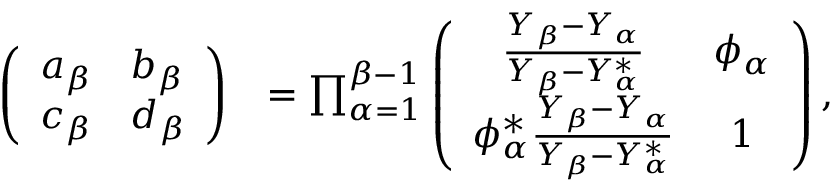<formula> <loc_0><loc_0><loc_500><loc_500>\begin{array} { r l } { \left ( \begin{array} { l l } { a _ { \beta } } & { b _ { \beta } } \\ { c _ { \beta } } & { d _ { \beta } } \end{array} \right ) } & { = \prod _ { \alpha = 1 } ^ { \beta - 1 } \left ( \begin{array} { c c } { \frac { Y _ { \beta } - Y _ { \alpha } } { Y _ { \beta } - Y _ { \alpha } ^ { * } } } & { \phi _ { \alpha } } \\ { \phi _ { \alpha } ^ { * } \frac { Y _ { \beta } - Y _ { \alpha } } { Y _ { \beta } - Y _ { \alpha } ^ { * } } } & { 1 } \end{array} \right ) , } \end{array}</formula> 